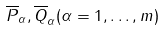<formula> <loc_0><loc_0><loc_500><loc_500>\overline { P } _ { \alpha } , \overline { Q } _ { \alpha } ( \alpha = 1 , \dots , m )</formula> 